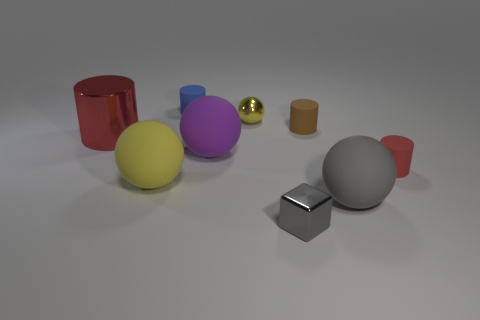What material is the red cylinder that is left of the yellow object that is in front of the large red metal cylinder?
Provide a succinct answer. Metal. Is there another metal thing that has the same shape as the purple thing?
Provide a succinct answer. Yes. There is a metal sphere that is the same size as the metallic block; what color is it?
Ensure brevity in your answer.  Yellow. How many things are either spheres in front of the big red cylinder or tiny cylinders that are behind the tiny red matte cylinder?
Give a very brief answer. 5. How many things are small brown cylinders or yellow metal objects?
Your answer should be very brief. 2. How big is the metal object that is both behind the yellow rubber sphere and on the right side of the blue cylinder?
Your answer should be compact. Small. How many large cylinders are made of the same material as the small gray block?
Your response must be concise. 1. What color is the large cylinder that is made of the same material as the small block?
Your answer should be compact. Red. Does the big matte ball that is on the left side of the blue thing have the same color as the metallic ball?
Provide a short and direct response. Yes. What is the red cylinder that is on the left side of the small gray metal cube made of?
Offer a terse response. Metal. 